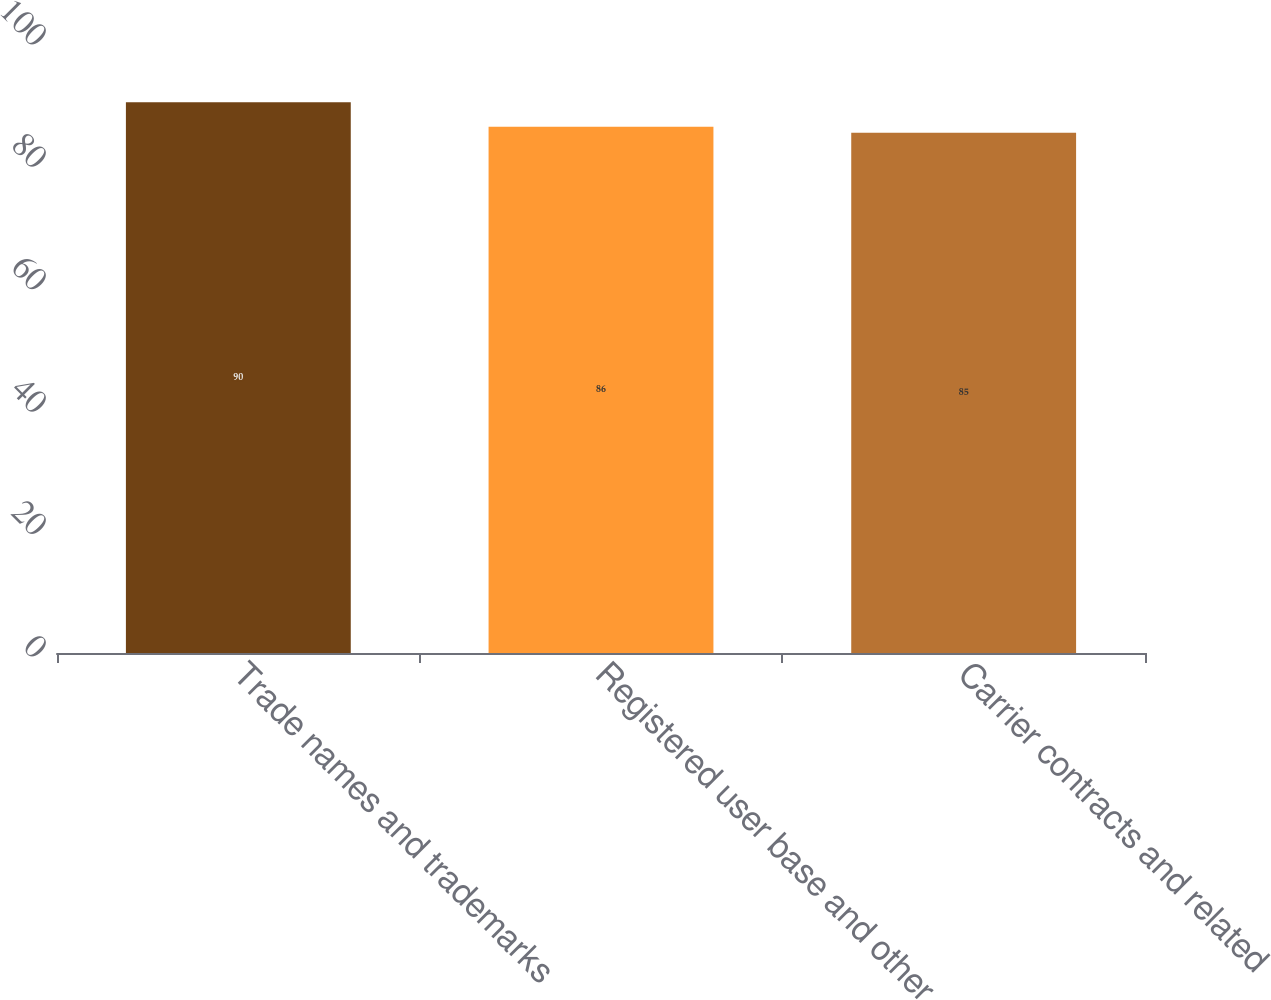Convert chart to OTSL. <chart><loc_0><loc_0><loc_500><loc_500><bar_chart><fcel>Trade names and trademarks<fcel>Registered user base and other<fcel>Carrier contracts and related<nl><fcel>90<fcel>86<fcel>85<nl></chart> 